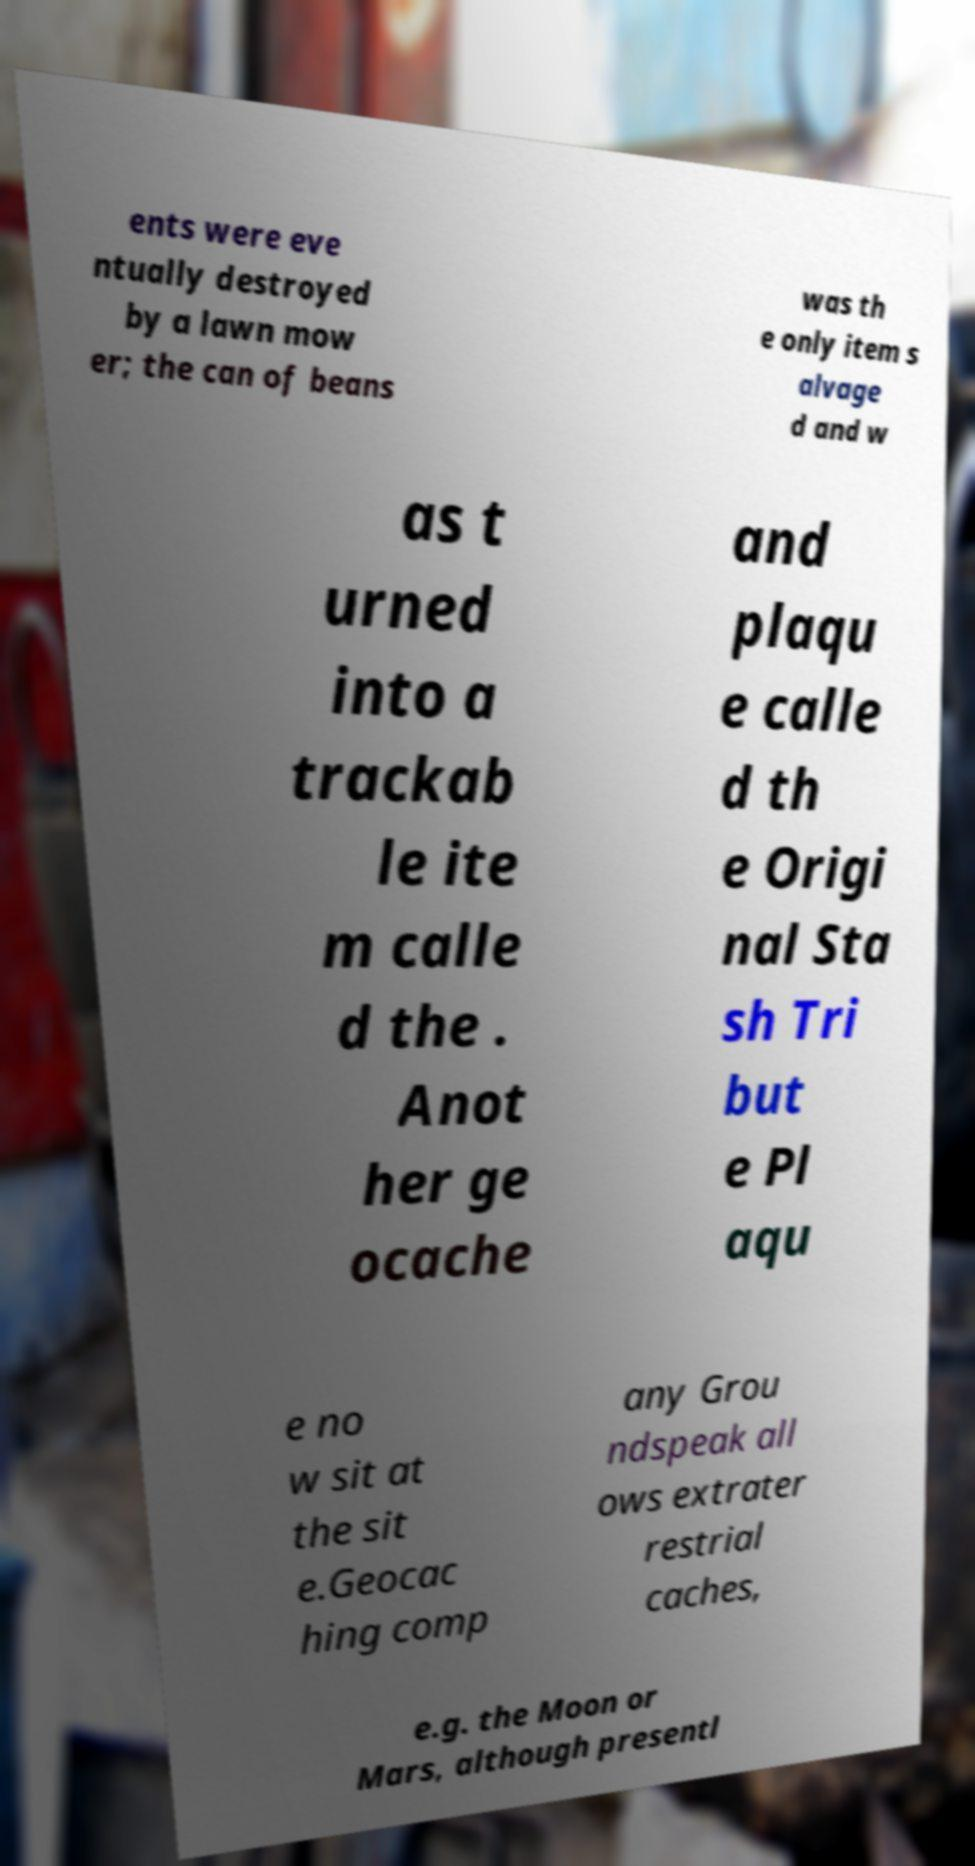Can you accurately transcribe the text from the provided image for me? ents were eve ntually destroyed by a lawn mow er; the can of beans was th e only item s alvage d and w as t urned into a trackab le ite m calle d the . Anot her ge ocache and plaqu e calle d th e Origi nal Sta sh Tri but e Pl aqu e no w sit at the sit e.Geocac hing comp any Grou ndspeak all ows extrater restrial caches, e.g. the Moon or Mars, although presentl 